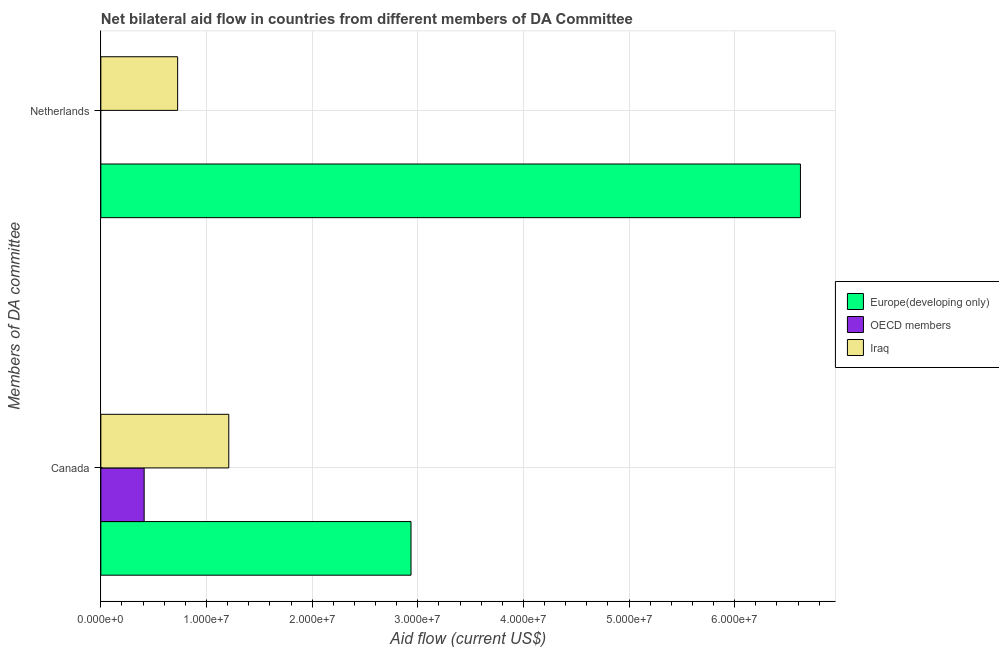Are the number of bars per tick equal to the number of legend labels?
Give a very brief answer. No. What is the amount of aid given by canada in Europe(developing only)?
Offer a terse response. 2.94e+07. Across all countries, what is the maximum amount of aid given by netherlands?
Your response must be concise. 6.62e+07. In which country was the amount of aid given by netherlands maximum?
Offer a terse response. Europe(developing only). What is the total amount of aid given by netherlands in the graph?
Your response must be concise. 7.35e+07. What is the difference between the amount of aid given by canada in Iraq and that in Europe(developing only)?
Your answer should be compact. -1.72e+07. What is the difference between the amount of aid given by netherlands in OECD members and the amount of aid given by canada in Europe(developing only)?
Offer a terse response. -2.94e+07. What is the average amount of aid given by netherlands per country?
Your answer should be compact. 2.45e+07. What is the difference between the amount of aid given by canada and amount of aid given by netherlands in Europe(developing only)?
Keep it short and to the point. -3.69e+07. In how many countries, is the amount of aid given by canada greater than 16000000 US$?
Make the answer very short. 1. What is the ratio of the amount of aid given by canada in OECD members to that in Iraq?
Keep it short and to the point. 0.34. Is the amount of aid given by netherlands in Iraq less than that in Europe(developing only)?
Provide a short and direct response. Yes. How many bars are there?
Keep it short and to the point. 5. What is the difference between two consecutive major ticks on the X-axis?
Your response must be concise. 1.00e+07. Where does the legend appear in the graph?
Ensure brevity in your answer.  Center right. What is the title of the graph?
Offer a very short reply. Net bilateral aid flow in countries from different members of DA Committee. Does "Equatorial Guinea" appear as one of the legend labels in the graph?
Give a very brief answer. No. What is the label or title of the X-axis?
Make the answer very short. Aid flow (current US$). What is the label or title of the Y-axis?
Make the answer very short. Members of DA committee. What is the Aid flow (current US$) of Europe(developing only) in Canada?
Offer a terse response. 2.94e+07. What is the Aid flow (current US$) in OECD members in Canada?
Ensure brevity in your answer.  4.10e+06. What is the Aid flow (current US$) of Iraq in Canada?
Give a very brief answer. 1.21e+07. What is the Aid flow (current US$) of Europe(developing only) in Netherlands?
Offer a terse response. 6.62e+07. What is the Aid flow (current US$) of OECD members in Netherlands?
Make the answer very short. 0. What is the Aid flow (current US$) in Iraq in Netherlands?
Provide a short and direct response. 7.27e+06. Across all Members of DA committee, what is the maximum Aid flow (current US$) in Europe(developing only)?
Keep it short and to the point. 6.62e+07. Across all Members of DA committee, what is the maximum Aid flow (current US$) of OECD members?
Provide a succinct answer. 4.10e+06. Across all Members of DA committee, what is the maximum Aid flow (current US$) of Iraq?
Offer a very short reply. 1.21e+07. Across all Members of DA committee, what is the minimum Aid flow (current US$) of Europe(developing only)?
Offer a terse response. 2.94e+07. Across all Members of DA committee, what is the minimum Aid flow (current US$) of Iraq?
Provide a succinct answer. 7.27e+06. What is the total Aid flow (current US$) of Europe(developing only) in the graph?
Offer a very short reply. 9.56e+07. What is the total Aid flow (current US$) in OECD members in the graph?
Your response must be concise. 4.10e+06. What is the total Aid flow (current US$) in Iraq in the graph?
Your answer should be compact. 1.94e+07. What is the difference between the Aid flow (current US$) of Europe(developing only) in Canada and that in Netherlands?
Provide a short and direct response. -3.69e+07. What is the difference between the Aid flow (current US$) of Iraq in Canada and that in Netherlands?
Make the answer very short. 4.84e+06. What is the difference between the Aid flow (current US$) in Europe(developing only) in Canada and the Aid flow (current US$) in Iraq in Netherlands?
Keep it short and to the point. 2.21e+07. What is the difference between the Aid flow (current US$) in OECD members in Canada and the Aid flow (current US$) in Iraq in Netherlands?
Offer a terse response. -3.17e+06. What is the average Aid flow (current US$) in Europe(developing only) per Members of DA committee?
Provide a succinct answer. 4.78e+07. What is the average Aid flow (current US$) in OECD members per Members of DA committee?
Provide a short and direct response. 2.05e+06. What is the average Aid flow (current US$) in Iraq per Members of DA committee?
Give a very brief answer. 9.69e+06. What is the difference between the Aid flow (current US$) in Europe(developing only) and Aid flow (current US$) in OECD members in Canada?
Your answer should be very brief. 2.53e+07. What is the difference between the Aid flow (current US$) in Europe(developing only) and Aid flow (current US$) in Iraq in Canada?
Give a very brief answer. 1.72e+07. What is the difference between the Aid flow (current US$) of OECD members and Aid flow (current US$) of Iraq in Canada?
Provide a short and direct response. -8.01e+06. What is the difference between the Aid flow (current US$) in Europe(developing only) and Aid flow (current US$) in Iraq in Netherlands?
Your answer should be compact. 5.90e+07. What is the ratio of the Aid flow (current US$) of Europe(developing only) in Canada to that in Netherlands?
Your answer should be compact. 0.44. What is the ratio of the Aid flow (current US$) of Iraq in Canada to that in Netherlands?
Provide a short and direct response. 1.67. What is the difference between the highest and the second highest Aid flow (current US$) of Europe(developing only)?
Give a very brief answer. 3.69e+07. What is the difference between the highest and the second highest Aid flow (current US$) in Iraq?
Ensure brevity in your answer.  4.84e+06. What is the difference between the highest and the lowest Aid flow (current US$) in Europe(developing only)?
Give a very brief answer. 3.69e+07. What is the difference between the highest and the lowest Aid flow (current US$) of OECD members?
Provide a short and direct response. 4.10e+06. What is the difference between the highest and the lowest Aid flow (current US$) of Iraq?
Your answer should be very brief. 4.84e+06. 